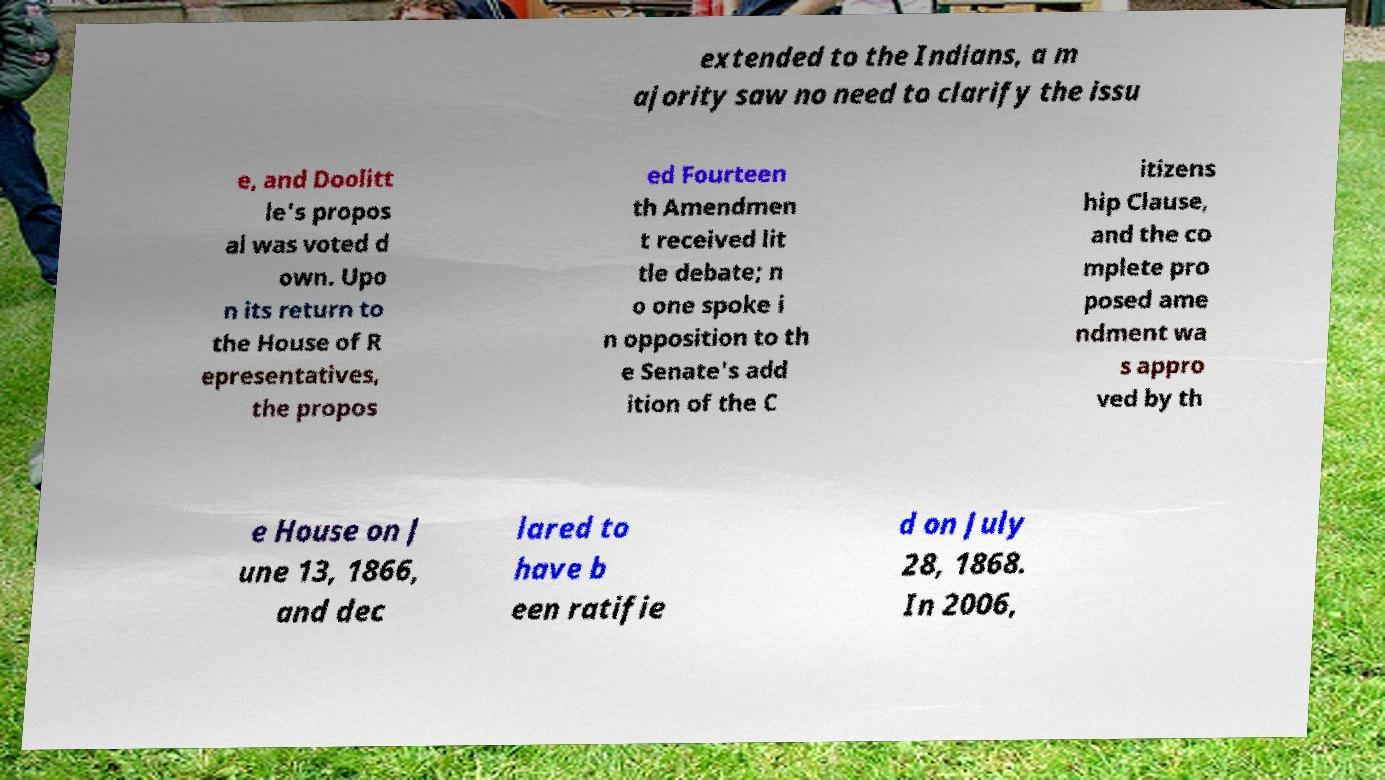Could you assist in decoding the text presented in this image and type it out clearly? extended to the Indians, a m ajority saw no need to clarify the issu e, and Doolitt le's propos al was voted d own. Upo n its return to the House of R epresentatives, the propos ed Fourteen th Amendmen t received lit tle debate; n o one spoke i n opposition to th e Senate's add ition of the C itizens hip Clause, and the co mplete pro posed ame ndment wa s appro ved by th e House on J une 13, 1866, and dec lared to have b een ratifie d on July 28, 1868. In 2006, 